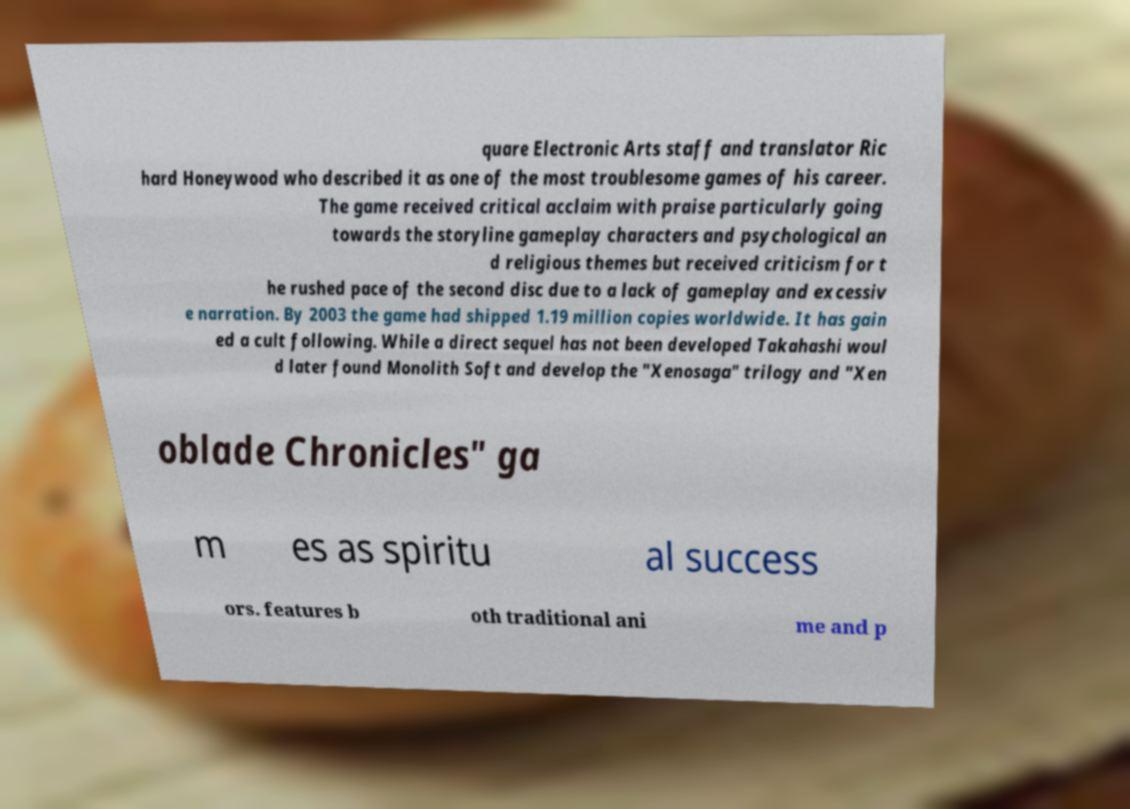Can you read and provide the text displayed in the image?This photo seems to have some interesting text. Can you extract and type it out for me? quare Electronic Arts staff and translator Ric hard Honeywood who described it as one of the most troublesome games of his career. The game received critical acclaim with praise particularly going towards the storyline gameplay characters and psychological an d religious themes but received criticism for t he rushed pace of the second disc due to a lack of gameplay and excessiv e narration. By 2003 the game had shipped 1.19 million copies worldwide. It has gain ed a cult following. While a direct sequel has not been developed Takahashi woul d later found Monolith Soft and develop the "Xenosaga" trilogy and "Xen oblade Chronicles" ga m es as spiritu al success ors. features b oth traditional ani me and p 